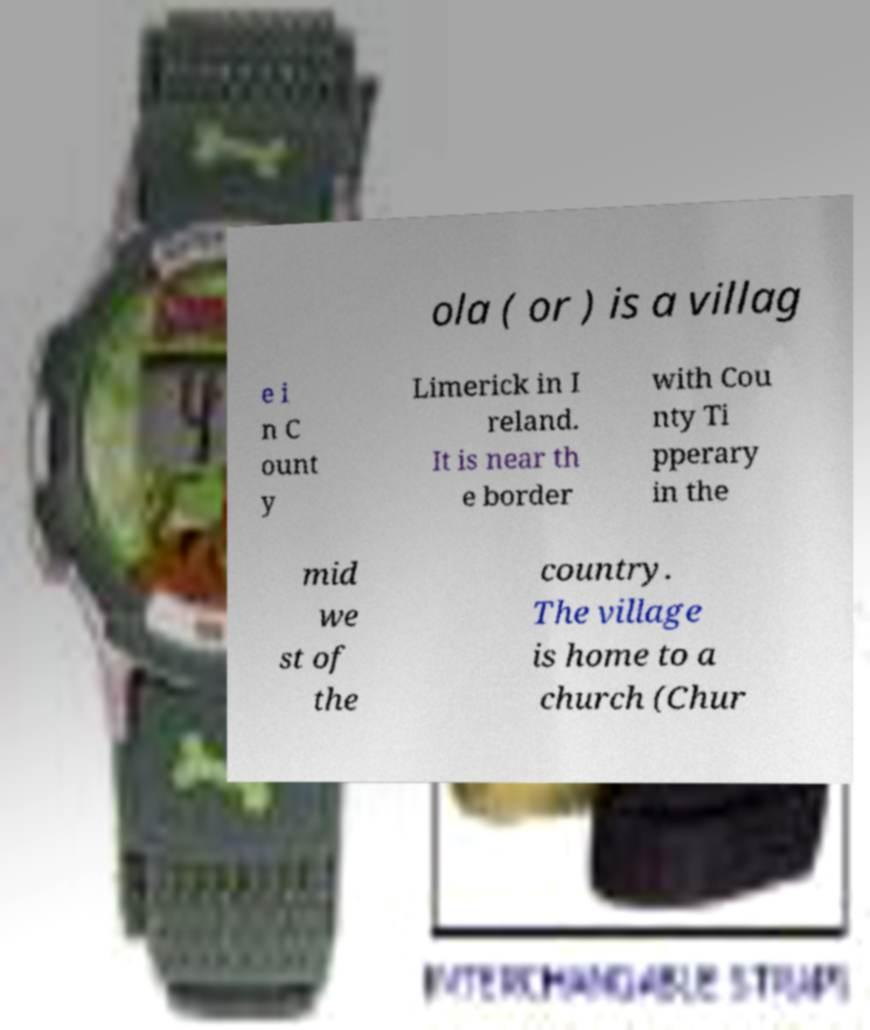For documentation purposes, I need the text within this image transcribed. Could you provide that? ola ( or ) is a villag e i n C ount y Limerick in I reland. It is near th e border with Cou nty Ti pperary in the mid we st of the country. The village is home to a church (Chur 